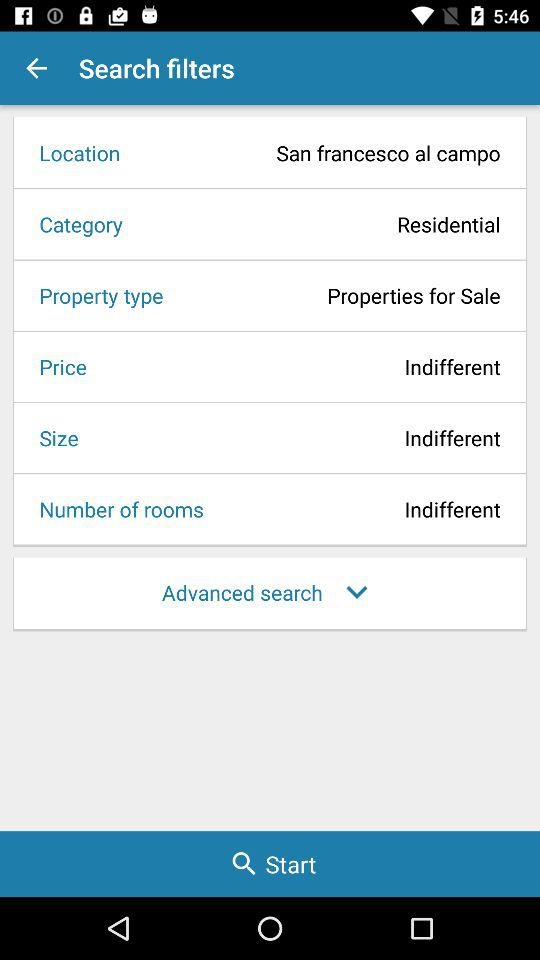What is the size? The size is "Indifferent". 